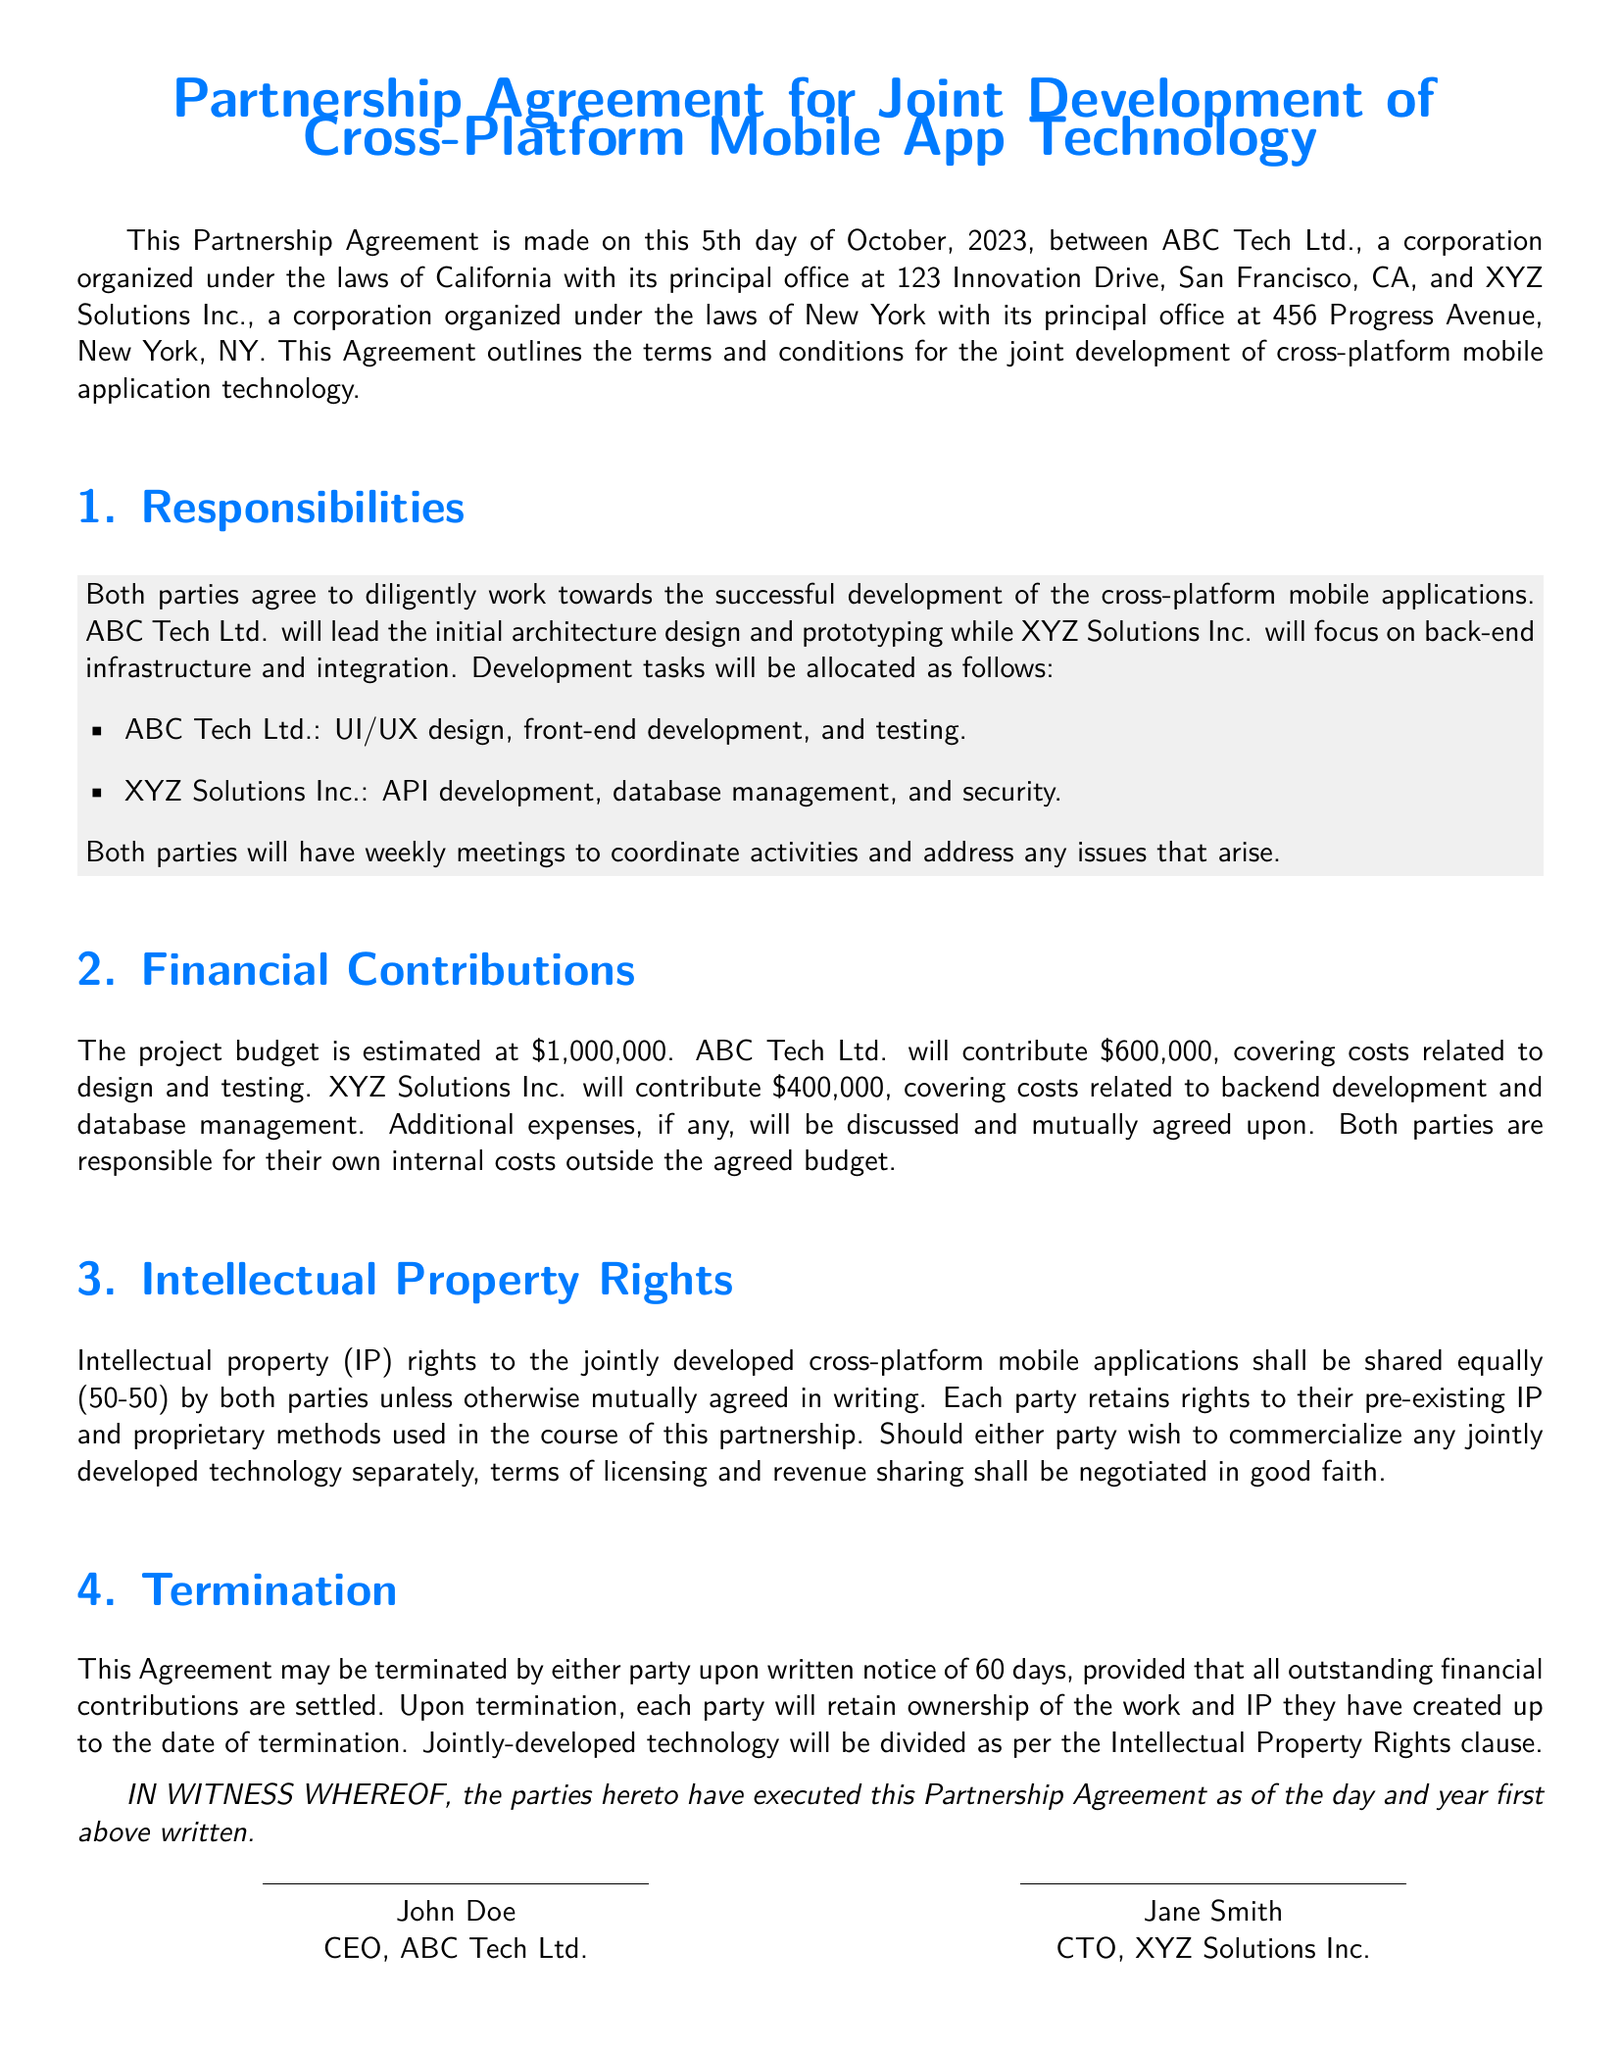What is the date of the agreement? The agreement is made on the 5th day of October, 2023, as stated at the beginning of the document.
Answer: October 5, 2023 Who contributes more financially? The financial contributions detail that ABC Tech Ltd. contributes $600,000, which is more than what XYZ Solutions Inc. contributes.
Answer: ABC Tech Ltd What is the total project budget? The budget for the project is estimated at $1,000,000, as per the financial contributions section.
Answer: $1,000,000 Which company is responsible for UI/UX design? The responsibilities section specifies that ABC Tech Ltd. is responsible for UI/UX design.
Answer: ABC Tech Ltd What is the shared ownership percentage of IP rights? The document indicates that intellectual property rights are shared equally, which means each party has a 50% ownership.
Answer: 50% What must happen before termination of the agreement? The termination clause specifies that either party must provide written notice of 60 days before termination, and all outstanding financial contributions must be settled.
Answer: Written notice of 60 days What type of technology are the parties developing? The title of the document makes it clear that the partnership is for the joint development of cross-platform mobile app technology.
Answer: Cross-platform mobile app technology Who leads initial architecture design? The responsibilities section states that ABC Tech Ltd. will lead the initial architecture design and prototyping.
Answer: ABC Tech Ltd What is the role of XYZ Solutions Inc. in development? The responsibilities section outlines that XYZ Solutions Inc. will focus on back-end infrastructure and integration in the project.
Answer: Back-end infrastructure and integration 